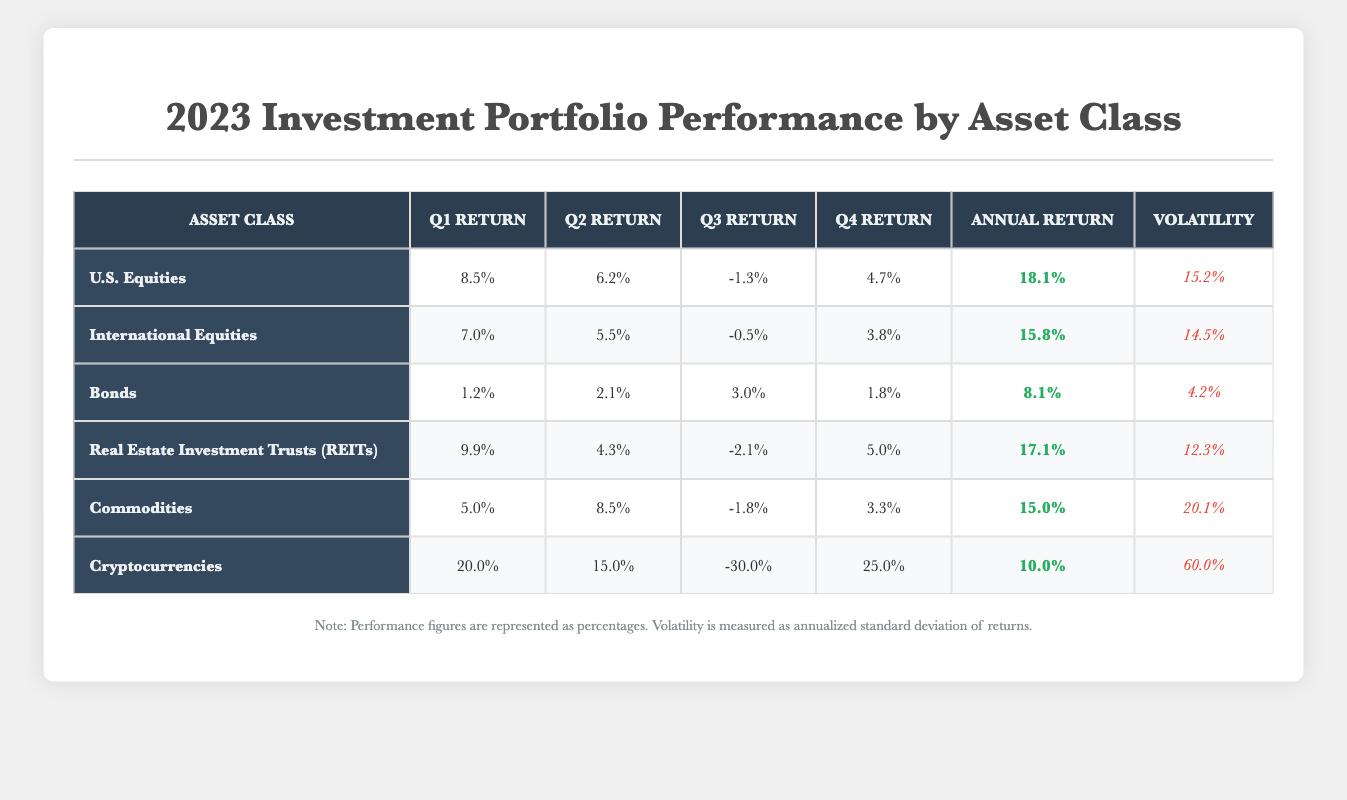What was the highest annual return among the asset classes? By examining the "Annual Return" column, the highest value is found for "U.S. Equities" at 18.1%.
Answer: 18.1% Which asset class had the lowest volatility? Looking at the "Volatility" column, "Bonds" has the lowest value of 4.2%.
Answer: 4.2% Calculate the average quarterly return of "Real Estate Investment Trusts (REITs)". Add the quarterly returns: (9.9 + 4.3 - 2.1 + 5.0) = 17.1. Divide by 4: 17.1 / 4 = 4.275%.
Answer: 4.275% Did "Cryptocurrencies" have negative returns in any quarter? Checking the "Q3 Return" for "Cryptocurrencies," it shows -30.0%, confirming there was a negative return.
Answer: Yes What was the total annual return of "Commodities" and "Bonds"? Adding the annual returns: 15.0% (Commodities) + 8.1% (Bonds) = 23.1%.
Answer: 23.1% Which asset class showed the highest performance in Q1? In the "Q1 Return" column, "Cryptocurrencies" tops the list with a return of 20.0%.
Answer: 20.0% How much did "International Equities" return in Q3 compared to "U.S. Equities"? The Q3 Return for "International Equities" is -0.5%, and for "U.S. Equities" is -1.3%. Comparing these, -0.5% is higher than -1.3%, thus it performed better.
Answer: Better by 0.8% If you combine the annual returns of "Bonds" and "Real Estate Investment Trusts (REITs)", how do they compare to "International Equities"? The total annual return of "Bonds" and "REITs" is 8.1% + 17.1% = 25.2%. This exceeds "International Equities's" annual return of 15.8%.
Answer: Yes, they exceed In which quarter did "Commodities" experience the lowest return? The "Q3 Return" for "Commodities" is the lowest at -1.8%.
Answer: Q3 What can be said about the performance trend of "Cryptocurrencies" throughout 2023? "Cryptocurrencies" started strong in Q1 (20.0%) but saw a significant drop in Q3 to -30.0%. The trend shows high volatility and inconsistent performance.
Answer: Highly volatile and inconsistent 